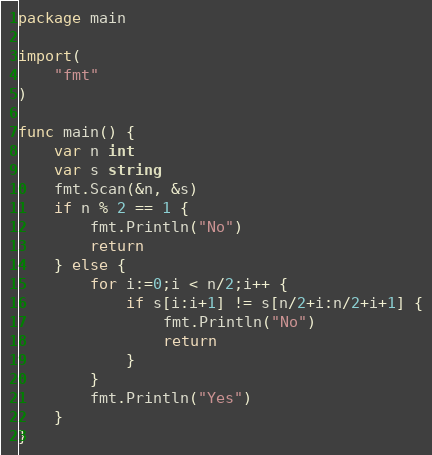Convert code to text. <code><loc_0><loc_0><loc_500><loc_500><_Go_>package main

import(
    "fmt"
)

func main() {
    var n int
    var s string
    fmt.Scan(&n, &s)
    if n % 2 == 1 {
        fmt.Println("No")
        return
    } else {
        for i:=0;i < n/2;i++ {
            if s[i:i+1] != s[n/2+i:n/2+i+1] {
                fmt.Println("No")
                return
            } 
        }
        fmt.Println("Yes")
    }
}

</code> 